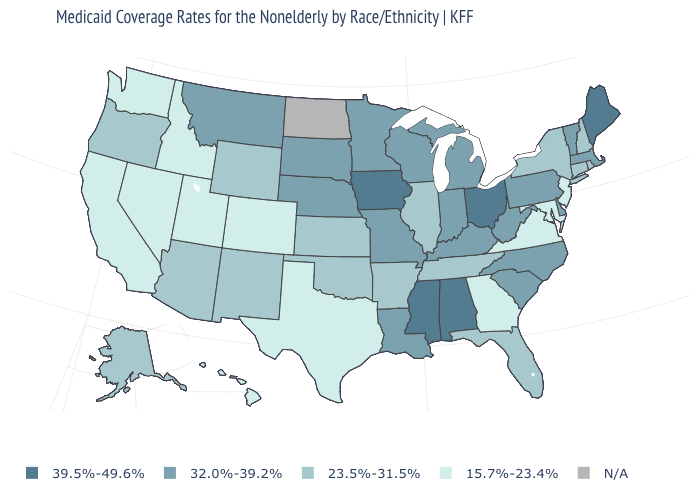What is the lowest value in the West?
Give a very brief answer. 15.7%-23.4%. What is the value of North Dakota?
Answer briefly. N/A. What is the value of North Carolina?
Quick response, please. 32.0%-39.2%. Does the first symbol in the legend represent the smallest category?
Concise answer only. No. Which states have the lowest value in the USA?
Concise answer only. California, Colorado, Georgia, Hawaii, Idaho, Maryland, Nevada, New Jersey, Texas, Utah, Virginia, Washington. Is the legend a continuous bar?
Short answer required. No. What is the lowest value in the USA?
Write a very short answer. 15.7%-23.4%. What is the highest value in the USA?
Concise answer only. 39.5%-49.6%. Name the states that have a value in the range 23.5%-31.5%?
Answer briefly. Alaska, Arizona, Arkansas, Connecticut, Florida, Illinois, Kansas, New Hampshire, New Mexico, New York, Oklahoma, Oregon, Rhode Island, Tennessee, Wyoming. Does the first symbol in the legend represent the smallest category?
Answer briefly. No. What is the value of Ohio?
Concise answer only. 39.5%-49.6%. What is the lowest value in states that border Oklahoma?
Concise answer only. 15.7%-23.4%. What is the value of Iowa?
Be succinct. 39.5%-49.6%. What is the value of West Virginia?
Write a very short answer. 32.0%-39.2%. 